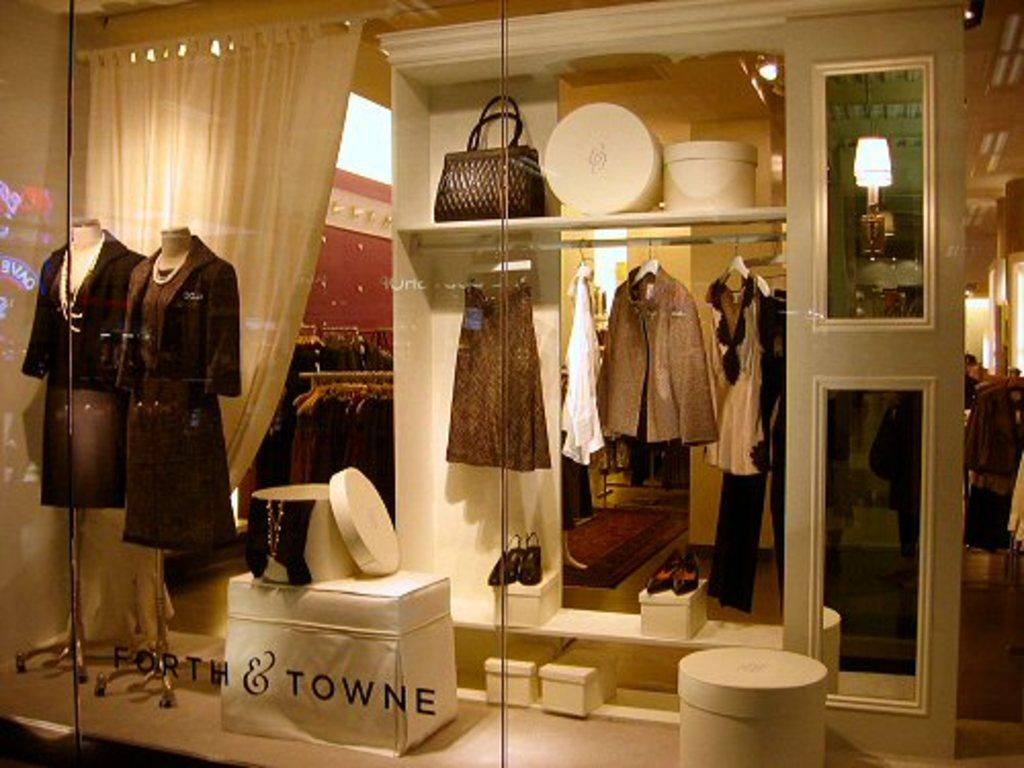<image>
Relay a brief, clear account of the picture shown. A dress aquamarine display behind glass for Forth and Towne. 